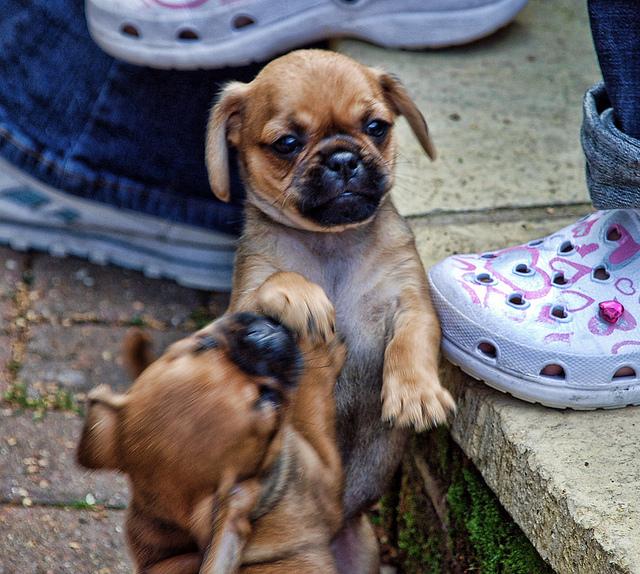What design is on the shoe?
Quick response, please. Hearts. What are this guys doing?
Short answer required. Playing. Are these dogs fighting?
Concise answer only. No. 